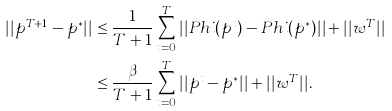<formula> <loc_0><loc_0><loc_500><loc_500>| | p ^ { T + 1 } - p ^ { \ast } | | & \leq \frac { 1 } { T + 1 } \sum _ { t = 0 } ^ { T } | | { P h i } ( p ^ { t } ) - { P h i } ( p ^ { \ast } ) | | + | | w ^ { T } | | \\ & \leq \frac { \beta } { T + 1 } \sum _ { t = 0 } ^ { T } | | p ^ { t } - p ^ { \ast } | | + | | w ^ { T } | | .</formula> 